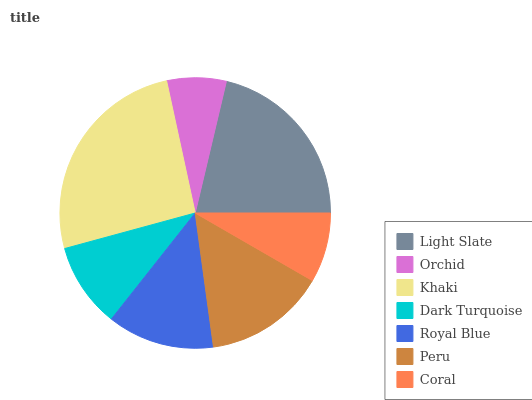Is Orchid the minimum?
Answer yes or no. Yes. Is Khaki the maximum?
Answer yes or no. Yes. Is Khaki the minimum?
Answer yes or no. No. Is Orchid the maximum?
Answer yes or no. No. Is Khaki greater than Orchid?
Answer yes or no. Yes. Is Orchid less than Khaki?
Answer yes or no. Yes. Is Orchid greater than Khaki?
Answer yes or no. No. Is Khaki less than Orchid?
Answer yes or no. No. Is Royal Blue the high median?
Answer yes or no. Yes. Is Royal Blue the low median?
Answer yes or no. Yes. Is Peru the high median?
Answer yes or no. No. Is Khaki the low median?
Answer yes or no. No. 